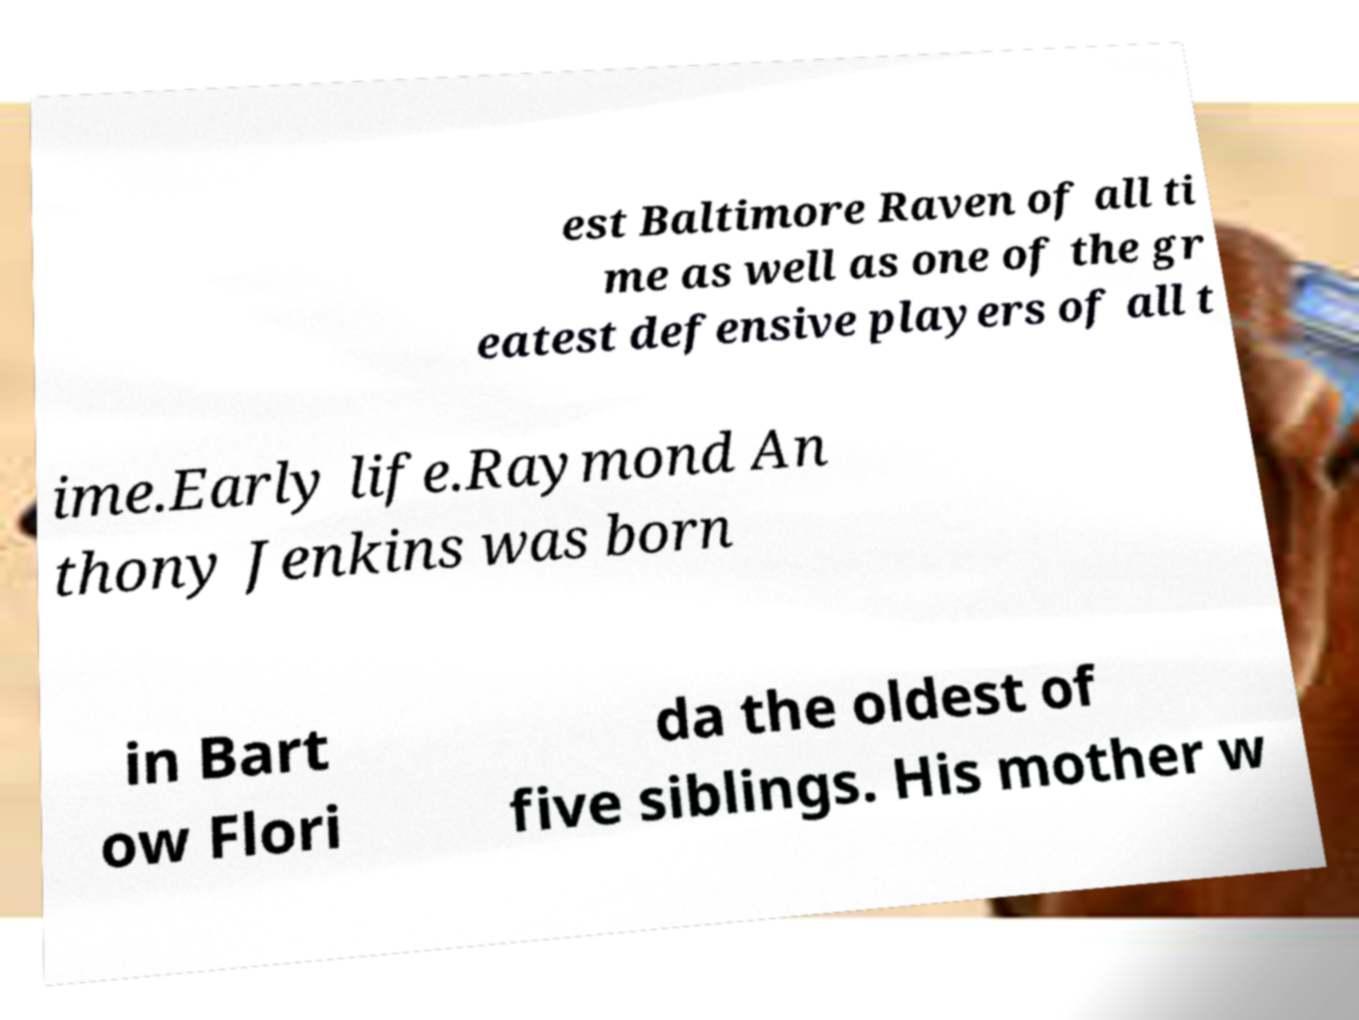Can you read and provide the text displayed in the image?This photo seems to have some interesting text. Can you extract and type it out for me? est Baltimore Raven of all ti me as well as one of the gr eatest defensive players of all t ime.Early life.Raymond An thony Jenkins was born in Bart ow Flori da the oldest of five siblings. His mother w 